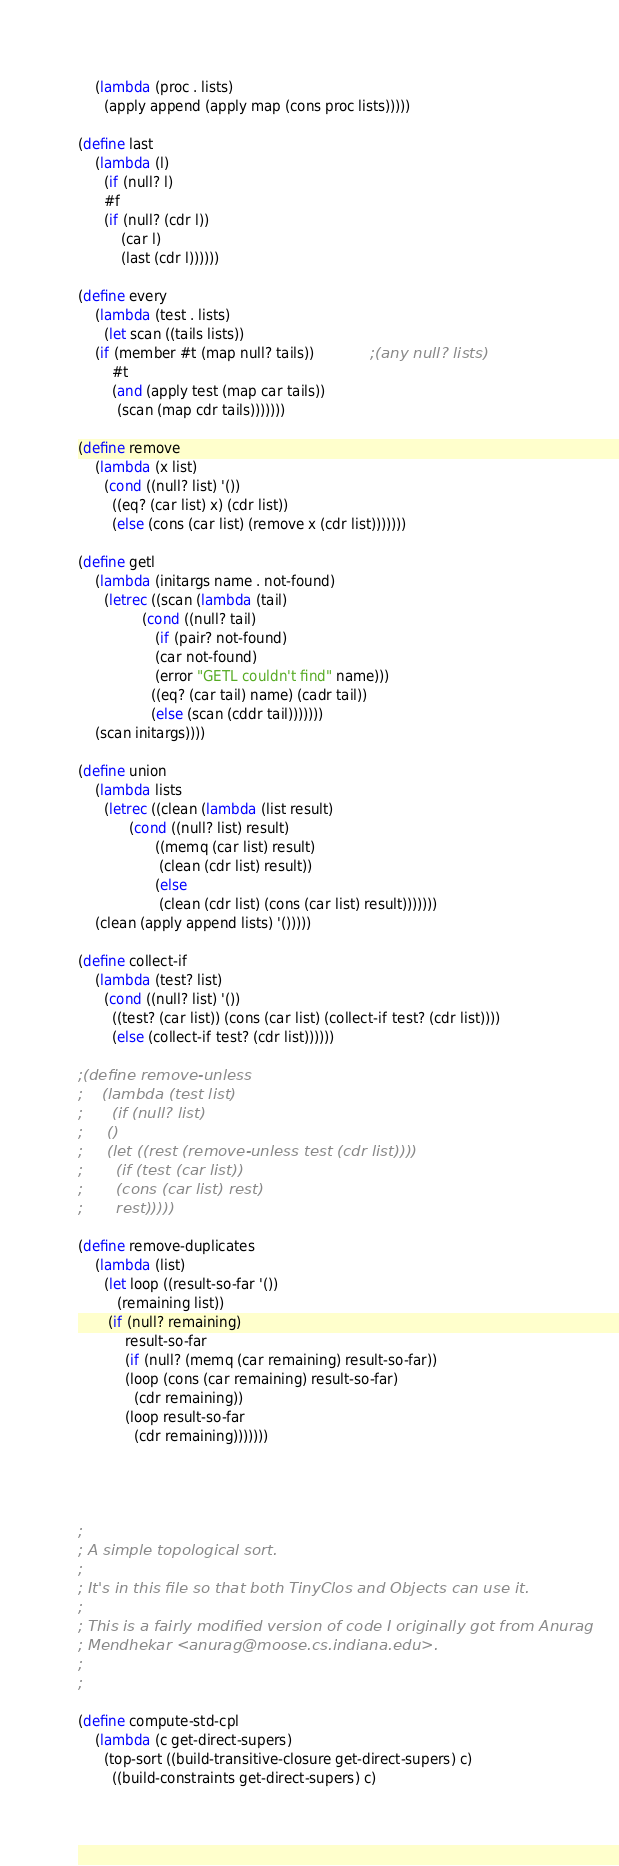<code> <loc_0><loc_0><loc_500><loc_500><_Scheme_>    (lambda (proc . lists)
      (apply append (apply map (cons proc lists)))))

(define last
    (lambda (l)
      (if (null? l)
	  #f
	  (if (null? (cdr l))
	      (car l)
	      (last (cdr l))))))

(define every
    (lambda (test . lists)
      (let scan ((tails lists))
	(if (member #t (map null? tails))             ;(any null? lists)
	    #t
	    (and (apply test (map car tails))
		 (scan (map cdr tails)))))))

(define remove
    (lambda (x list)
      (cond ((null? list) '())
	    ((eq? (car list) x) (cdr list))
	    (else (cons (car list) (remove x (cdr list)))))))

(define getl
    (lambda (initargs name . not-found)
      (letrec ((scan (lambda (tail)
		       (cond ((null? tail)
			      (if (pair? not-found)
				  (car not-found)
				  (error "GETL couldn't find" name)))
			     ((eq? (car tail) name) (cadr tail))
			     (else (scan (cddr tail)))))))
	(scan initargs))))

(define union
    (lambda lists
      (letrec ((clean (lambda (list result)
			(cond ((null? list) result)
			      ((memq (car list) result)
			       (clean (cdr list) result))
			      (else
			       (clean (cdr list) (cons (car list) result)))))))
	(clean (apply append lists) '()))))

(define collect-if
    (lambda (test? list)
      (cond ((null? list) '())
	    ((test? (car list)) (cons (car list) (collect-if test? (cdr list))))
	    (else (collect-if test? (cdr list))))))

;(define remove-unless
;    (lambda (test list)
;      (if (null? list)
;	  ()
;	  (let ((rest (remove-unless test (cdr list))))
;	    (if (test (car list))
;		(cons (car list) rest)
;		rest)))))

(define remove-duplicates
    (lambda (list)
      (let loop ((result-so-far '())
		 (remaining list))
	   (if (null? remaining)
	       result-so-far
	       (if (null? (memq (car remaining) result-so-far))
		   (loop (cons (car remaining) result-so-far)
			 (cdr remaining))
		   (loop result-so-far
			 (cdr remaining)))))))




;
; A simple topological sort.
;
; It's in this file so that both TinyClos and Objects can use it.
;
; This is a fairly modified version of code I originally got from Anurag
; Mendhekar <anurag@moose.cs.indiana.edu>.
;
;

(define compute-std-cpl
    (lambda (c get-direct-supers)
      (top-sort ((build-transitive-closure get-direct-supers) c)
		((build-constraints get-direct-supers) c)</code> 